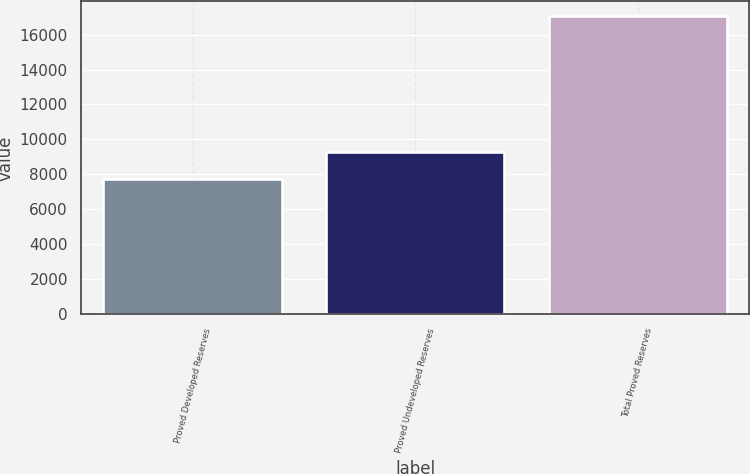<chart> <loc_0><loc_0><loc_500><loc_500><bar_chart><fcel>Proved Developed Reserves<fcel>Proved Undeveloped Reserves<fcel>Total Proved Reserves<nl><fcel>7757<fcel>9288<fcel>17045<nl></chart> 